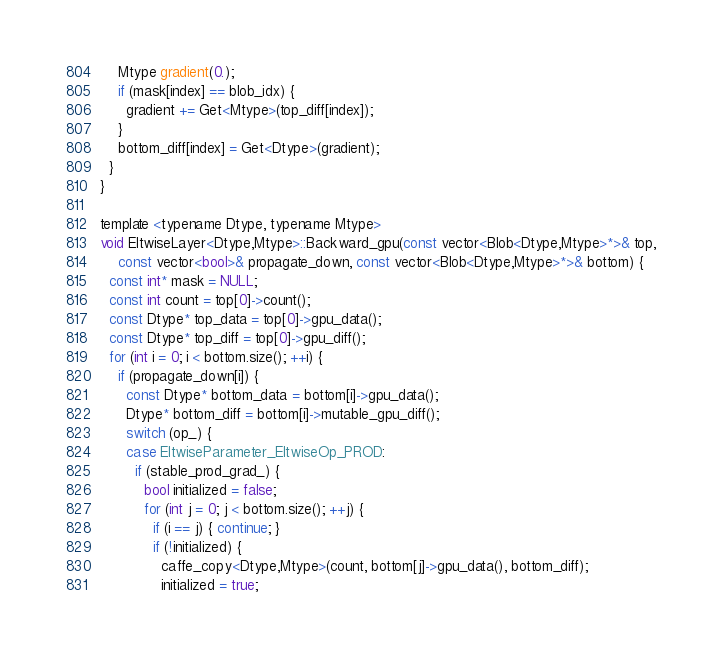<code> <loc_0><loc_0><loc_500><loc_500><_Cuda_>    Mtype gradient(0.);
    if (mask[index] == blob_idx) {
      gradient += Get<Mtype>(top_diff[index]);
    }
    bottom_diff[index] = Get<Dtype>(gradient);
  }
}

template <typename Dtype, typename Mtype>
void EltwiseLayer<Dtype,Mtype>::Backward_gpu(const vector<Blob<Dtype,Mtype>*>& top,
    const vector<bool>& propagate_down, const vector<Blob<Dtype,Mtype>*>& bottom) {
  const int* mask = NULL;
  const int count = top[0]->count();
  const Dtype* top_data = top[0]->gpu_data();
  const Dtype* top_diff = top[0]->gpu_diff();
  for (int i = 0; i < bottom.size(); ++i) {
    if (propagate_down[i]) {
      const Dtype* bottom_data = bottom[i]->gpu_data();
      Dtype* bottom_diff = bottom[i]->mutable_gpu_diff();
      switch (op_) {
      case EltwiseParameter_EltwiseOp_PROD:
        if (stable_prod_grad_) {
          bool initialized = false;
          for (int j = 0; j < bottom.size(); ++j) {
            if (i == j) { continue; }
            if (!initialized) {
              caffe_copy<Dtype,Mtype>(count, bottom[j]->gpu_data(), bottom_diff);
              initialized = true;</code> 